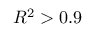<formula> <loc_0><loc_0><loc_500><loc_500>R ^ { 2 } > 0 . 9</formula> 